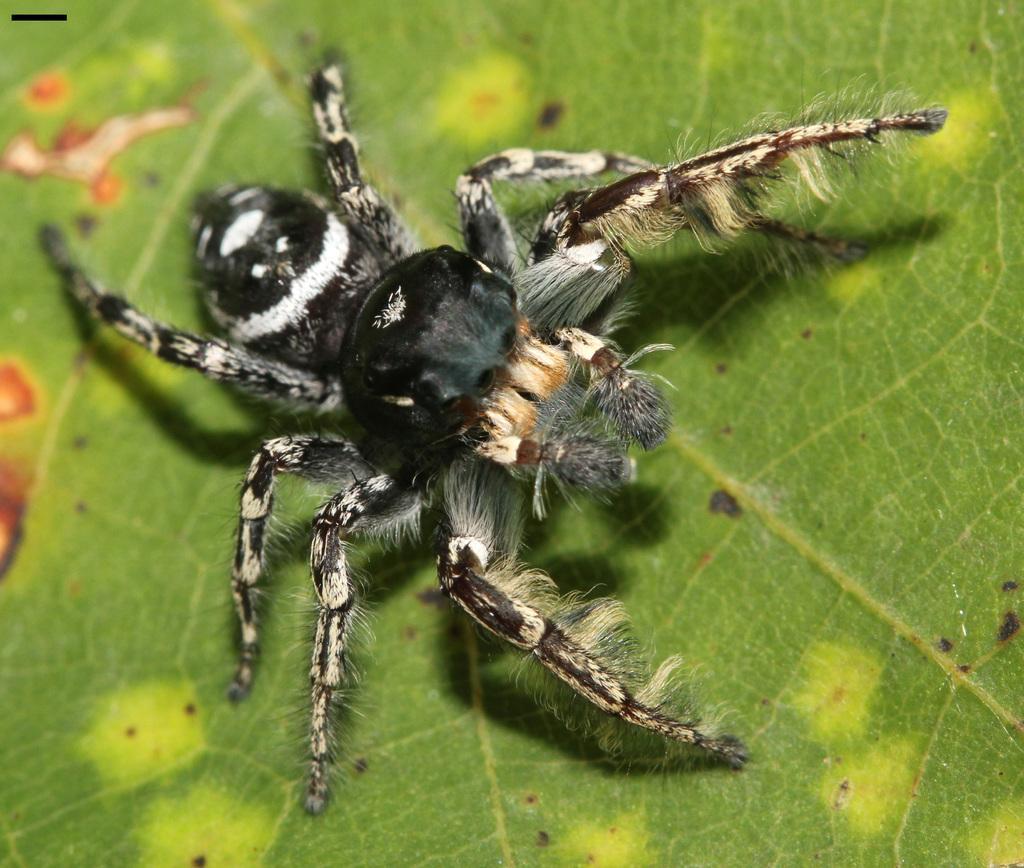Please provide a concise description of this image. This image consists of a spider in black color. It is on the leaf. The leaf is in green color. 